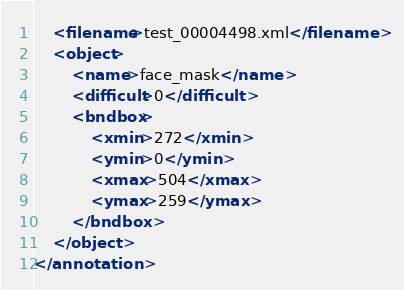<code> <loc_0><loc_0><loc_500><loc_500><_XML_>	<filename>test_00004498.xml</filename>
	<object>
		<name>face_mask</name>
		<difficult>0</difficult>
		<bndbox>
			<xmin>272</xmin>
			<ymin>0</ymin>
			<xmax>504</xmax>
			<ymax>259</ymax>
		</bndbox>
	</object>
</annotation>
</code> 